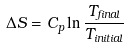<formula> <loc_0><loc_0><loc_500><loc_500>\Delta S = C _ { p } \ln \frac { T _ { f i n a l } } { T _ { i n i t i a l } }</formula> 